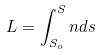Convert formula to latex. <formula><loc_0><loc_0><loc_500><loc_500>L = \int _ { S _ { o } } ^ { S } n d s</formula> 